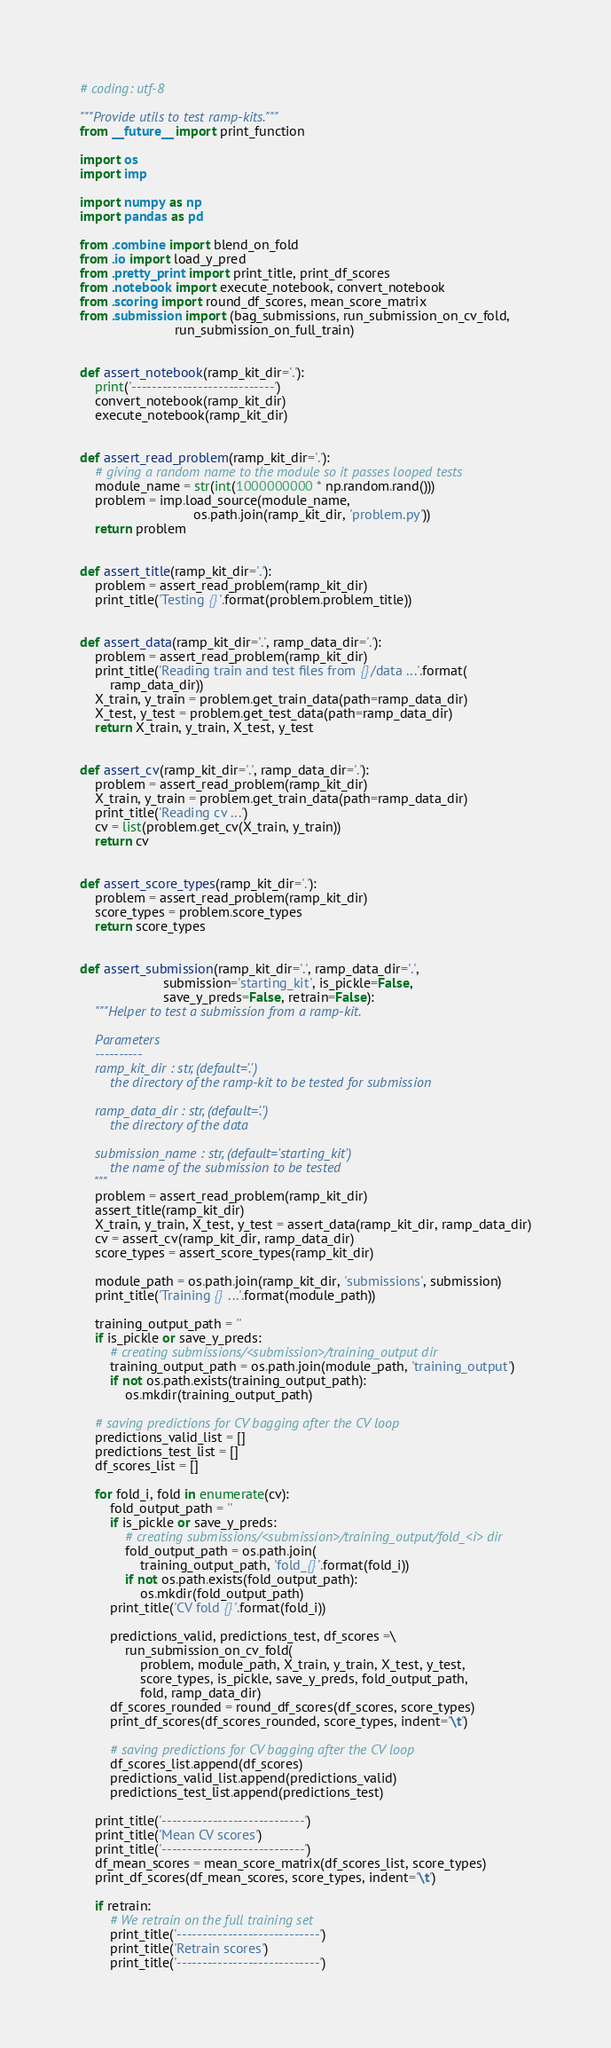Convert code to text. <code><loc_0><loc_0><loc_500><loc_500><_Python_># coding: utf-8

"""Provide utils to test ramp-kits."""
from __future__ import print_function

import os
import imp

import numpy as np
import pandas as pd

from .combine import blend_on_fold
from .io import load_y_pred
from .pretty_print import print_title, print_df_scores
from .notebook import execute_notebook, convert_notebook
from .scoring import round_df_scores, mean_score_matrix
from .submission import (bag_submissions, run_submission_on_cv_fold,
                         run_submission_on_full_train)


def assert_notebook(ramp_kit_dir='.'):
    print('----------------------------')
    convert_notebook(ramp_kit_dir)
    execute_notebook(ramp_kit_dir)


def assert_read_problem(ramp_kit_dir='.'):
    # giving a random name to the module so it passes looped tests
    module_name = str(int(1000000000 * np.random.rand()))
    problem = imp.load_source(module_name,
                              os.path.join(ramp_kit_dir, 'problem.py'))
    return problem


def assert_title(ramp_kit_dir='.'):
    problem = assert_read_problem(ramp_kit_dir)
    print_title('Testing {}'.format(problem.problem_title))


def assert_data(ramp_kit_dir='.', ramp_data_dir='.'):
    problem = assert_read_problem(ramp_kit_dir)
    print_title('Reading train and test files from {}/data ...'.format(
        ramp_data_dir))
    X_train, y_train = problem.get_train_data(path=ramp_data_dir)
    X_test, y_test = problem.get_test_data(path=ramp_data_dir)
    return X_train, y_train, X_test, y_test


def assert_cv(ramp_kit_dir='.', ramp_data_dir='.'):
    problem = assert_read_problem(ramp_kit_dir)
    X_train, y_train = problem.get_train_data(path=ramp_data_dir)
    print_title('Reading cv ...')
    cv = list(problem.get_cv(X_train, y_train))
    return cv


def assert_score_types(ramp_kit_dir='.'):
    problem = assert_read_problem(ramp_kit_dir)
    score_types = problem.score_types
    return score_types


def assert_submission(ramp_kit_dir='.', ramp_data_dir='.',
                      submission='starting_kit', is_pickle=False,
                      save_y_preds=False, retrain=False):
    """Helper to test a submission from a ramp-kit.

    Parameters
    ----------
    ramp_kit_dir : str, (default='.')
        the directory of the ramp-kit to be tested for submission

    ramp_data_dir : str, (default='.')
        the directory of the data

    submission_name : str, (default='starting_kit')
        the name of the submission to be tested
    """
    problem = assert_read_problem(ramp_kit_dir)
    assert_title(ramp_kit_dir)
    X_train, y_train, X_test, y_test = assert_data(ramp_kit_dir, ramp_data_dir)
    cv = assert_cv(ramp_kit_dir, ramp_data_dir)
    score_types = assert_score_types(ramp_kit_dir)

    module_path = os.path.join(ramp_kit_dir, 'submissions', submission)
    print_title('Training {} ...'.format(module_path))

    training_output_path = ''
    if is_pickle or save_y_preds:
        # creating submissions/<submission>/training_output dir
        training_output_path = os.path.join(module_path, 'training_output')
        if not os.path.exists(training_output_path):
            os.mkdir(training_output_path)

    # saving predictions for CV bagging after the CV loop
    predictions_valid_list = []
    predictions_test_list = []
    df_scores_list = []

    for fold_i, fold in enumerate(cv):
        fold_output_path = ''
        if is_pickle or save_y_preds:
            # creating submissions/<submission>/training_output/fold_<i> dir
            fold_output_path = os.path.join(
                training_output_path, 'fold_{}'.format(fold_i))
            if not os.path.exists(fold_output_path):
                os.mkdir(fold_output_path)
        print_title('CV fold {}'.format(fold_i))

        predictions_valid, predictions_test, df_scores =\
            run_submission_on_cv_fold(
                problem, module_path, X_train, y_train, X_test, y_test,
                score_types, is_pickle, save_y_preds, fold_output_path,
                fold, ramp_data_dir)
        df_scores_rounded = round_df_scores(df_scores, score_types)
        print_df_scores(df_scores_rounded, score_types, indent='\t')

        # saving predictions for CV bagging after the CV loop
        df_scores_list.append(df_scores)
        predictions_valid_list.append(predictions_valid)
        predictions_test_list.append(predictions_test)

    print_title('----------------------------')
    print_title('Mean CV scores')
    print_title('----------------------------')
    df_mean_scores = mean_score_matrix(df_scores_list, score_types)
    print_df_scores(df_mean_scores, score_types, indent='\t')

    if retrain:
        # We retrain on the full training set
        print_title('----------------------------')
        print_title('Retrain scores')
        print_title('----------------------------')</code> 